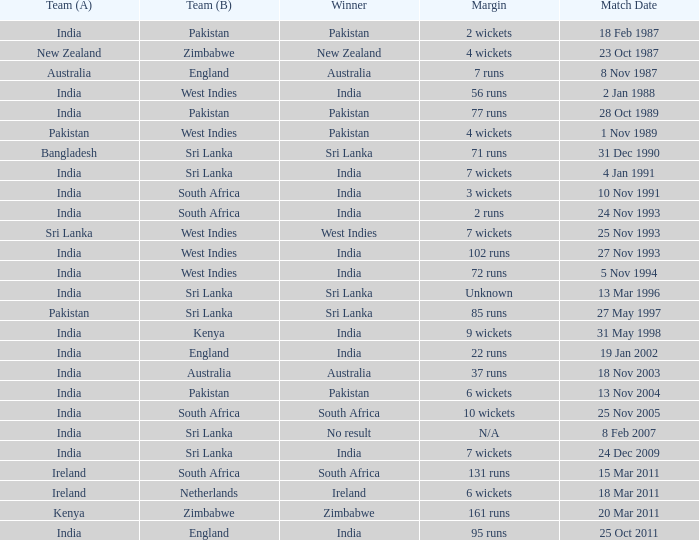What date did the West Indies win the match? 25 Nov 1993. 